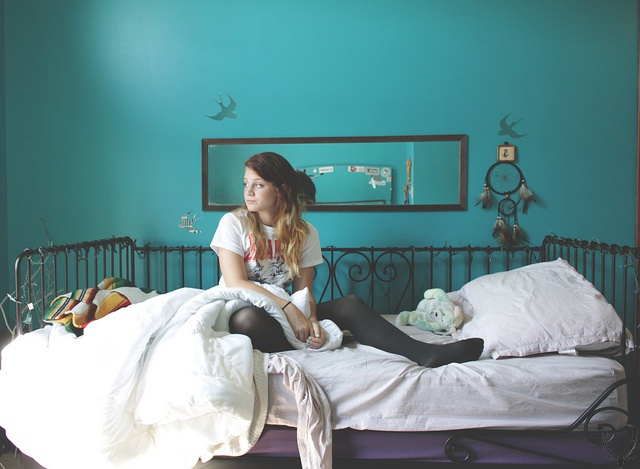Describe the objects in this image and their specific colors. I can see bed in purple, white, darkgray, teal, and gray tones, people in purple, black, gray, lightgray, and darkgray tones, teddy bear in purple, darkgray, lightblue, and lightgray tones, bird in purple and teal tones, and bird in purple and teal tones in this image. 